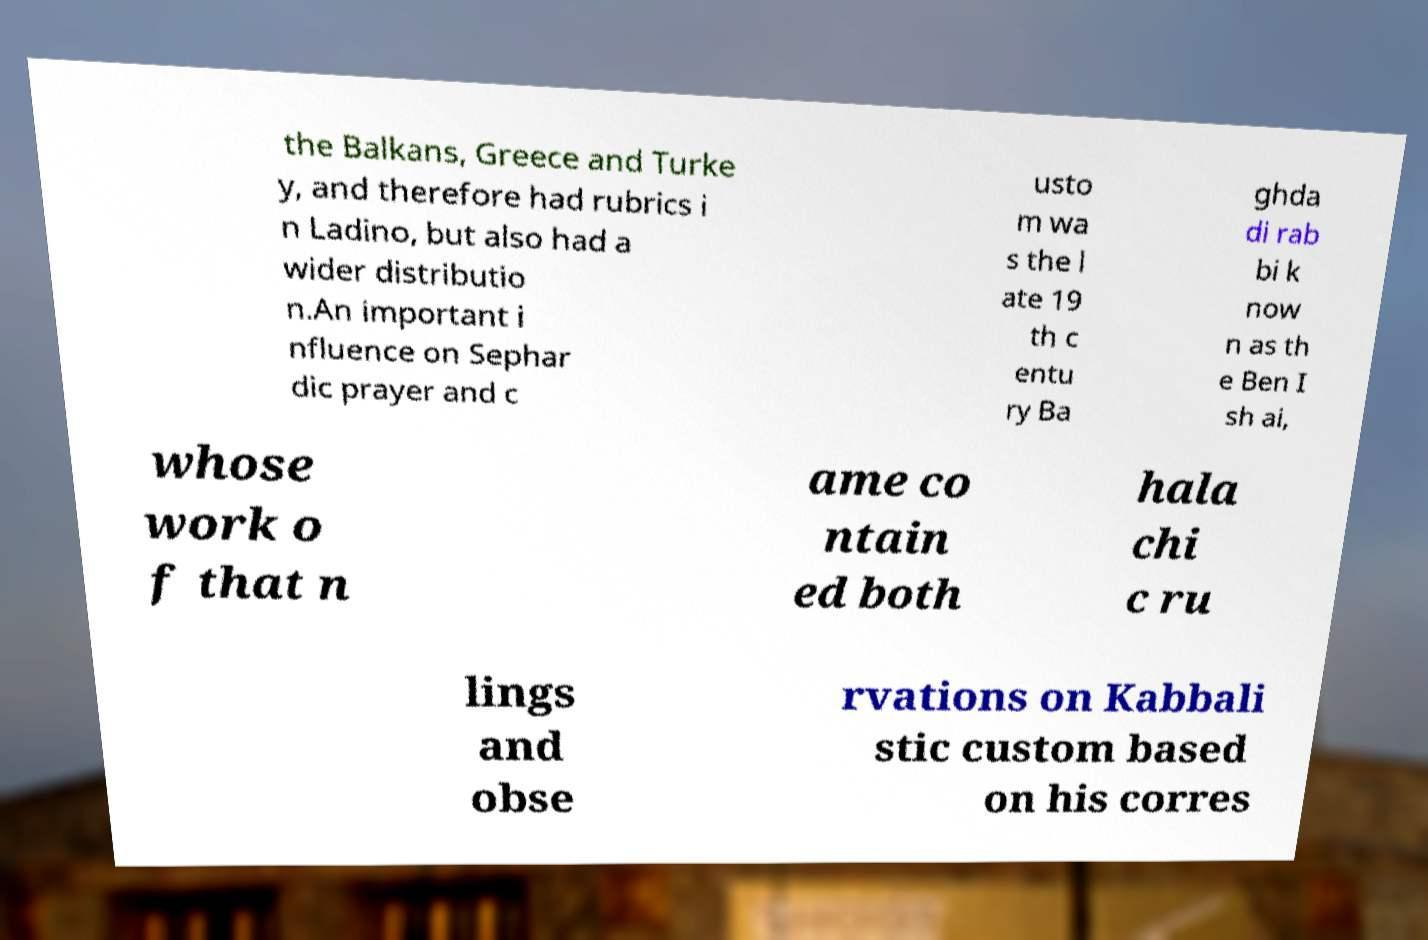Could you extract and type out the text from this image? the Balkans, Greece and Turke y, and therefore had rubrics i n Ladino, but also had a wider distributio n.An important i nfluence on Sephar dic prayer and c usto m wa s the l ate 19 th c entu ry Ba ghda di rab bi k now n as th e Ben I sh ai, whose work o f that n ame co ntain ed both hala chi c ru lings and obse rvations on Kabbali stic custom based on his corres 